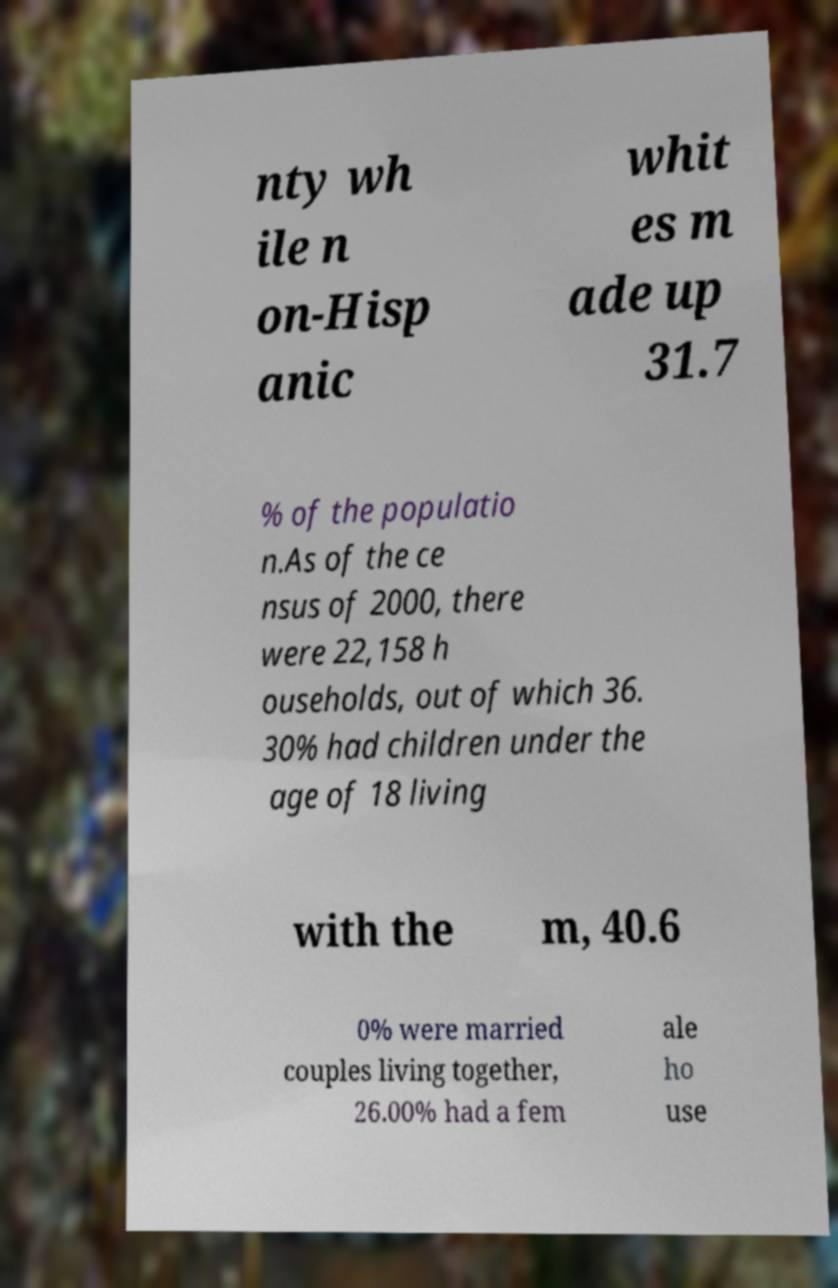For documentation purposes, I need the text within this image transcribed. Could you provide that? nty wh ile n on-Hisp anic whit es m ade up 31.7 % of the populatio n.As of the ce nsus of 2000, there were 22,158 h ouseholds, out of which 36. 30% had children under the age of 18 living with the m, 40.6 0% were married couples living together, 26.00% had a fem ale ho use 